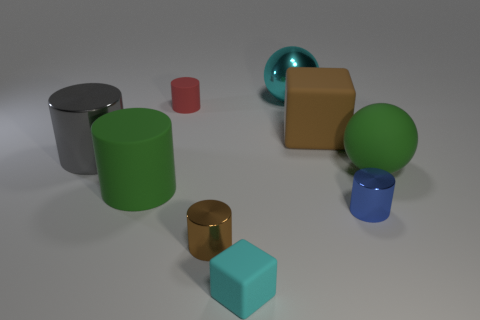Subtract all large green rubber cylinders. How many cylinders are left? 4 Add 1 brown rubber cylinders. How many objects exist? 10 Subtract all cyan balls. How many balls are left? 1 Subtract 1 balls. How many balls are left? 1 Add 6 small blue cylinders. How many small blue cylinders are left? 7 Add 3 tiny shiny cylinders. How many tiny shiny cylinders exist? 5 Subtract 1 red cylinders. How many objects are left? 8 Subtract all blocks. How many objects are left? 7 Subtract all purple cylinders. Subtract all purple balls. How many cylinders are left? 5 Subtract all metal things. Subtract all tiny gray shiny objects. How many objects are left? 5 